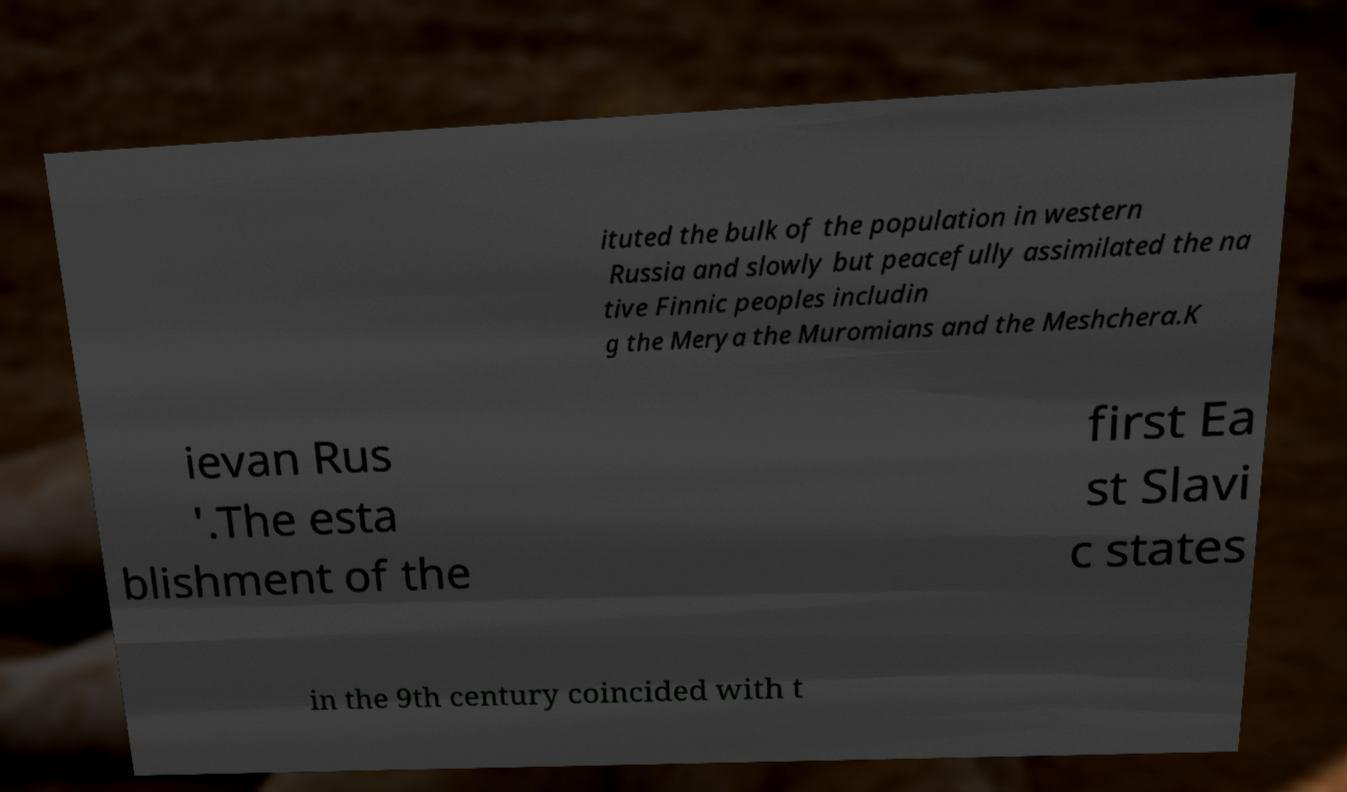Could you extract and type out the text from this image? ituted the bulk of the population in western Russia and slowly but peacefully assimilated the na tive Finnic peoples includin g the Merya the Muromians and the Meshchera.K ievan Rus '.The esta blishment of the first Ea st Slavi c states in the 9th century coincided with t 